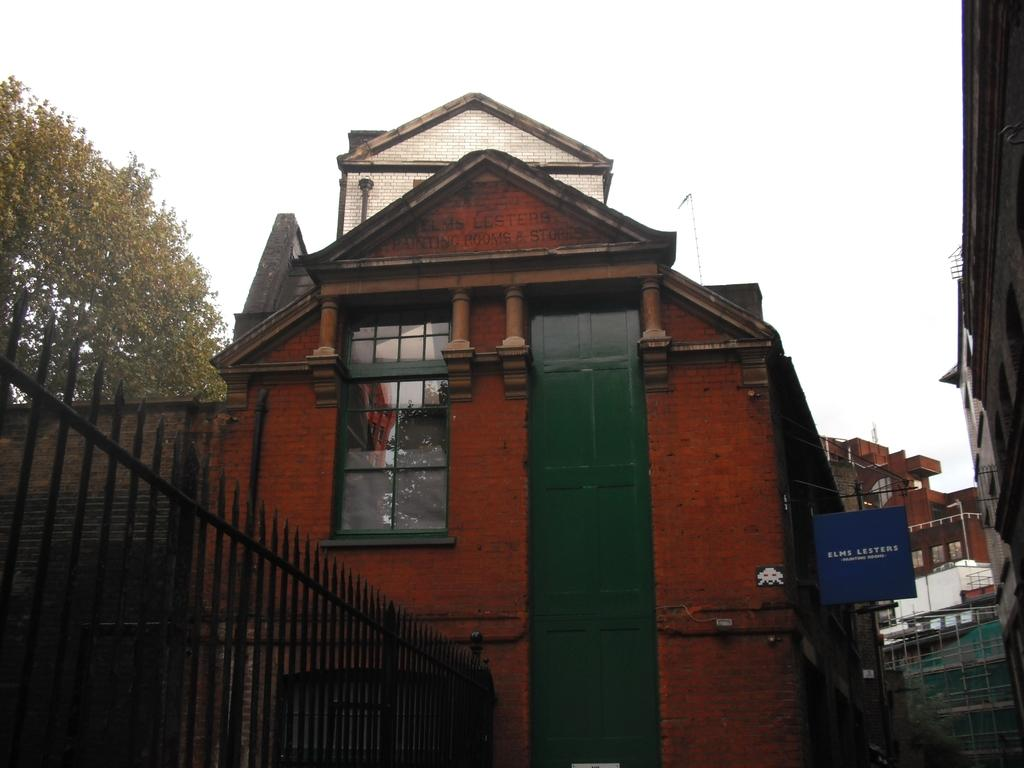What type of fencing is on the left side of the image? There is a black color fencing on the left side of the image. Where is the fencing located in relation to the building? The fencing is near a building. What feature can be observed on the building? The building has glass windows. What can be seen in the background of the image? There are buildings, trees, and the sky visible in the background of the image. How many brothers are visible in the image? There are no brothers present in the image. What type of blade can be seen in the image? There is no blade present in the image. 